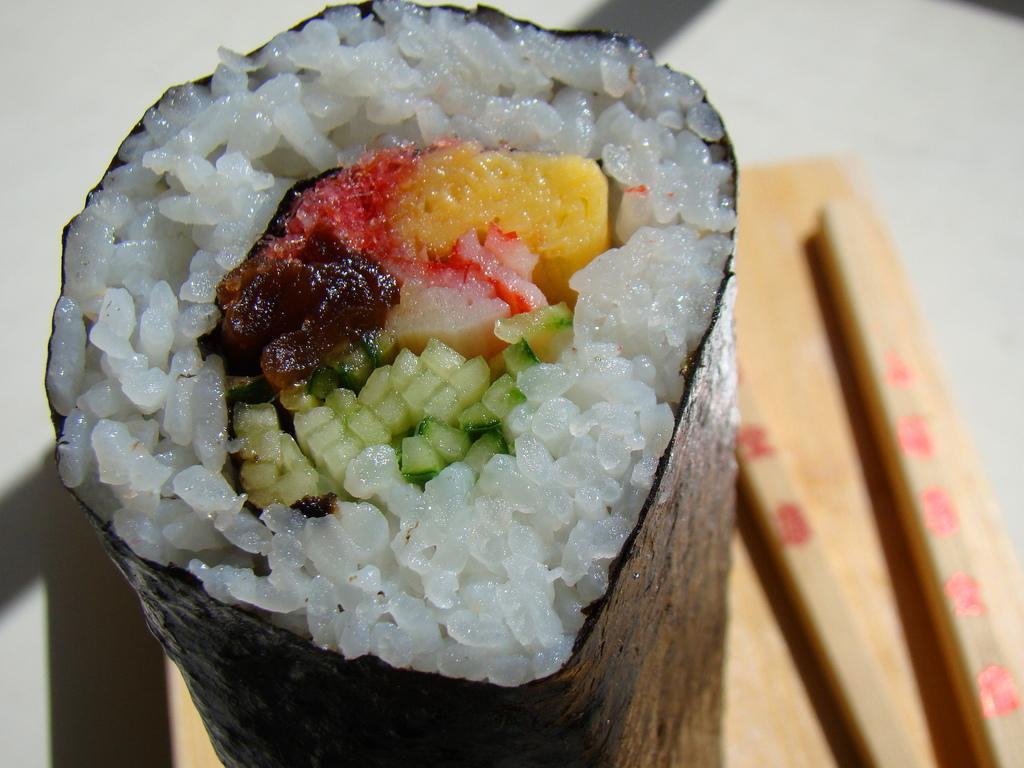In one or two sentences, can you explain what this image depicts? In this picture we can see some food item with rice wrapped in a paper this is placed on table and bedside to this we have two sticks. 